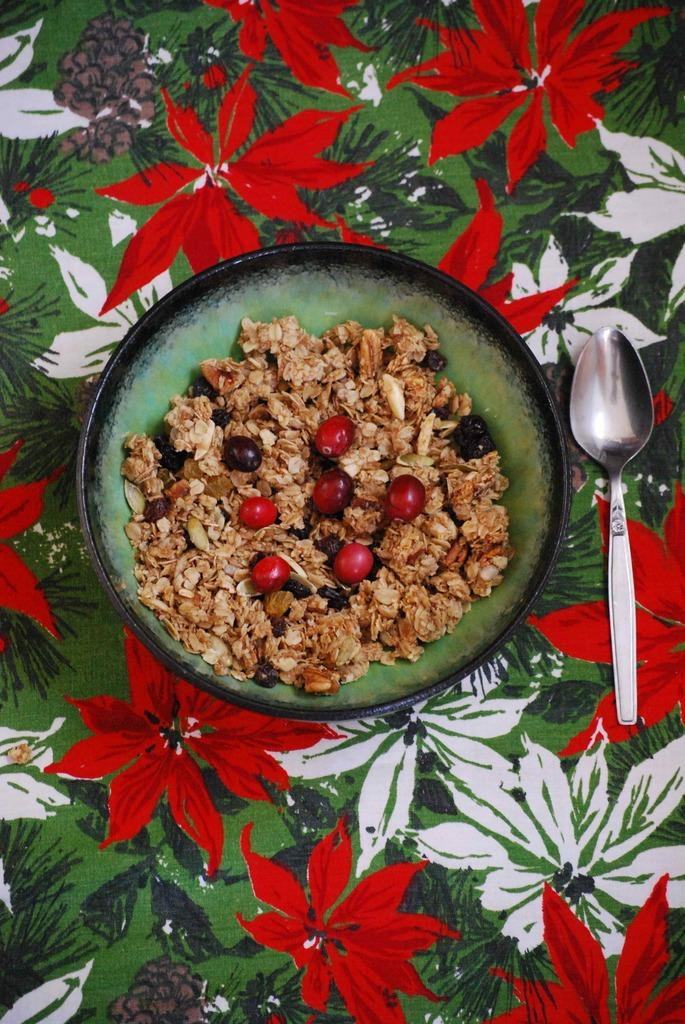What utensil is visible in the image? There is a spoon in the image. What is the spoon used for in the image? The spoon is likely used for eating the food in the bowl. What is in the bowl that is visible in the image? There is a bowl with food in the image. What type of yam is being served in the bowl in the image? There is no yam present in the image; it is a bowl with food, but the specific type of food is not mentioned. What country is the image taken in? The image does not provide any information about the country in which it was taken. 